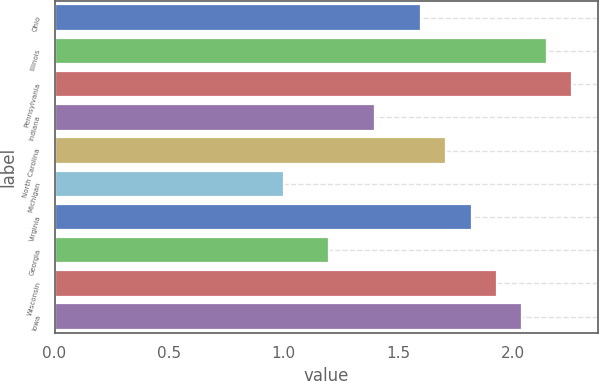<chart> <loc_0><loc_0><loc_500><loc_500><bar_chart><fcel>Ohio<fcel>Illinois<fcel>Pennsylvania<fcel>Indiana<fcel>North Carolina<fcel>Michigan<fcel>Virginia<fcel>Georgia<fcel>Wisconsin<fcel>Iowa<nl><fcel>1.6<fcel>2.15<fcel>2.26<fcel>1.4<fcel>1.71<fcel>1<fcel>1.82<fcel>1.2<fcel>1.93<fcel>2.04<nl></chart> 